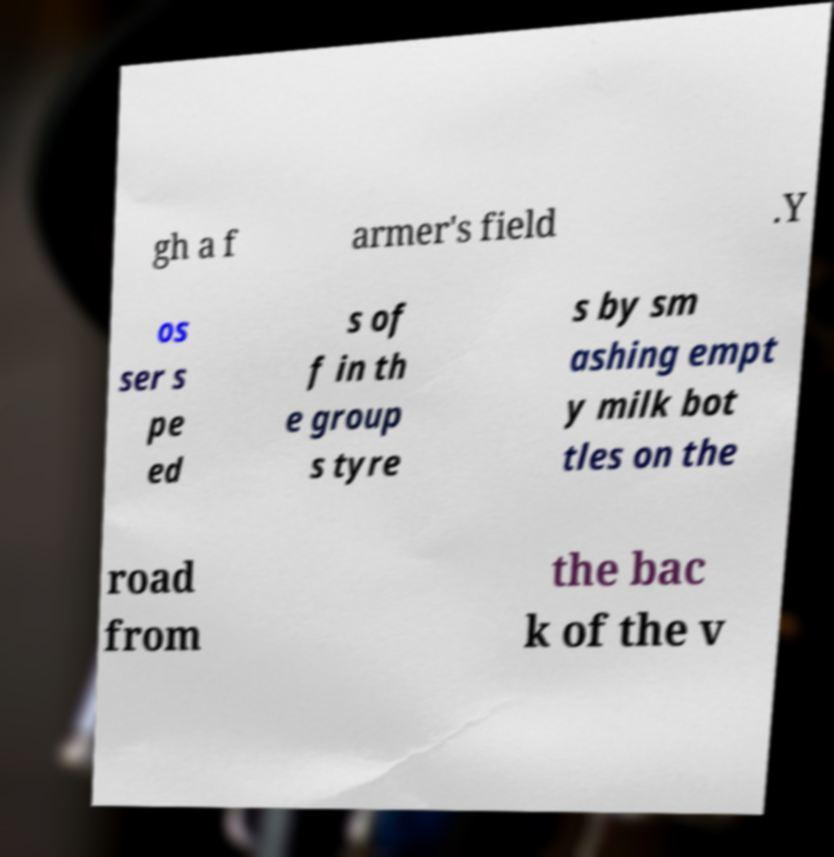What messages or text are displayed in this image? I need them in a readable, typed format. gh a f armer's field .Y os ser s pe ed s of f in th e group s tyre s by sm ashing empt y milk bot tles on the road from the bac k of the v 